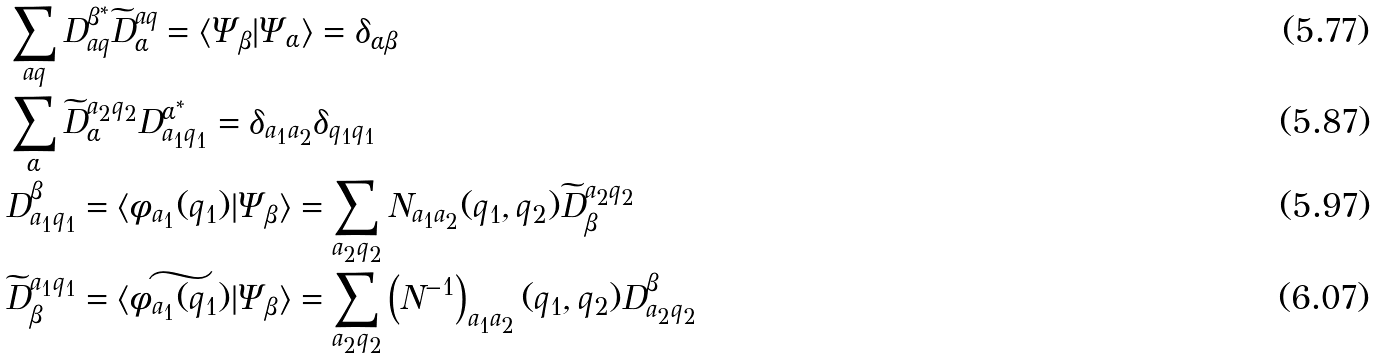<formula> <loc_0><loc_0><loc_500><loc_500>& \sum _ { a q } D ^ { \beta ^ { * } } _ { a q } \widetilde { D } _ { \alpha } ^ { a q } = \langle \Psi _ { \beta } | \Psi _ { \alpha } \rangle = \delta _ { \alpha \beta } \\ & \sum _ { \alpha } \widetilde { D } _ { \alpha } ^ { a _ { 2 } q _ { 2 } } D ^ { \alpha ^ { * } } _ { a _ { 1 } q _ { 1 } } = \delta _ { a _ { 1 } a _ { 2 } } \delta _ { q _ { 1 } q _ { 1 } } \\ & D ^ { \beta } _ { a _ { 1 } q _ { 1 } } = \langle \phi _ { a _ { 1 } } ( q _ { 1 } ) | \Psi _ { \beta } \rangle = \sum _ { a _ { 2 } q _ { 2 } } N _ { a _ { 1 } a _ { 2 } } ( q _ { 1 } , q _ { 2 } ) \widetilde { D } _ { \beta } ^ { a _ { 2 } q _ { 2 } } \\ & \widetilde { D } _ { \beta } ^ { a _ { 1 } q _ { 1 } } = \langle \widetilde { \phi _ { a _ { 1 } } ( q _ { 1 } ) } | \Psi _ { \beta } \rangle = \sum _ { a _ { 2 } q _ { 2 } } \left ( N ^ { - 1 } \right ) _ { a _ { 1 } a _ { 2 } } ( q _ { 1 } , q _ { 2 } ) D ^ { \beta } _ { a _ { 2 } q _ { 2 } }</formula> 